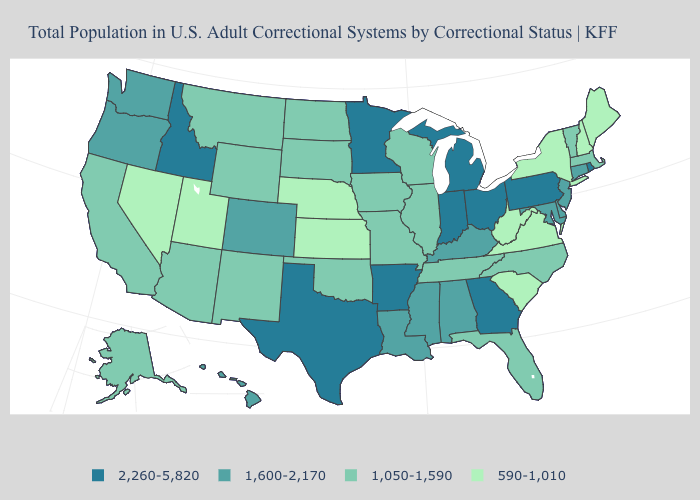Is the legend a continuous bar?
Keep it brief. No. Name the states that have a value in the range 1,050-1,590?
Write a very short answer. Alaska, Arizona, California, Florida, Illinois, Iowa, Massachusetts, Missouri, Montana, New Mexico, North Carolina, North Dakota, Oklahoma, South Dakota, Tennessee, Vermont, Wisconsin, Wyoming. What is the value of South Dakota?
Keep it brief. 1,050-1,590. What is the highest value in the MidWest ?
Short answer required. 2,260-5,820. Among the states that border South Carolina , which have the lowest value?
Quick response, please. North Carolina. What is the lowest value in the USA?
Be succinct. 590-1,010. Name the states that have a value in the range 1,050-1,590?
Be succinct. Alaska, Arizona, California, Florida, Illinois, Iowa, Massachusetts, Missouri, Montana, New Mexico, North Carolina, North Dakota, Oklahoma, South Dakota, Tennessee, Vermont, Wisconsin, Wyoming. Among the states that border Utah , which have the highest value?
Short answer required. Idaho. What is the value of Rhode Island?
Write a very short answer. 2,260-5,820. Which states have the highest value in the USA?
Short answer required. Arkansas, Georgia, Idaho, Indiana, Michigan, Minnesota, Ohio, Pennsylvania, Rhode Island, Texas. What is the value of Indiana?
Write a very short answer. 2,260-5,820. Among the states that border Michigan , which have the highest value?
Write a very short answer. Indiana, Ohio. Name the states that have a value in the range 2,260-5,820?
Concise answer only. Arkansas, Georgia, Idaho, Indiana, Michigan, Minnesota, Ohio, Pennsylvania, Rhode Island, Texas. Which states have the lowest value in the MidWest?
Short answer required. Kansas, Nebraska. What is the lowest value in the USA?
Short answer required. 590-1,010. 